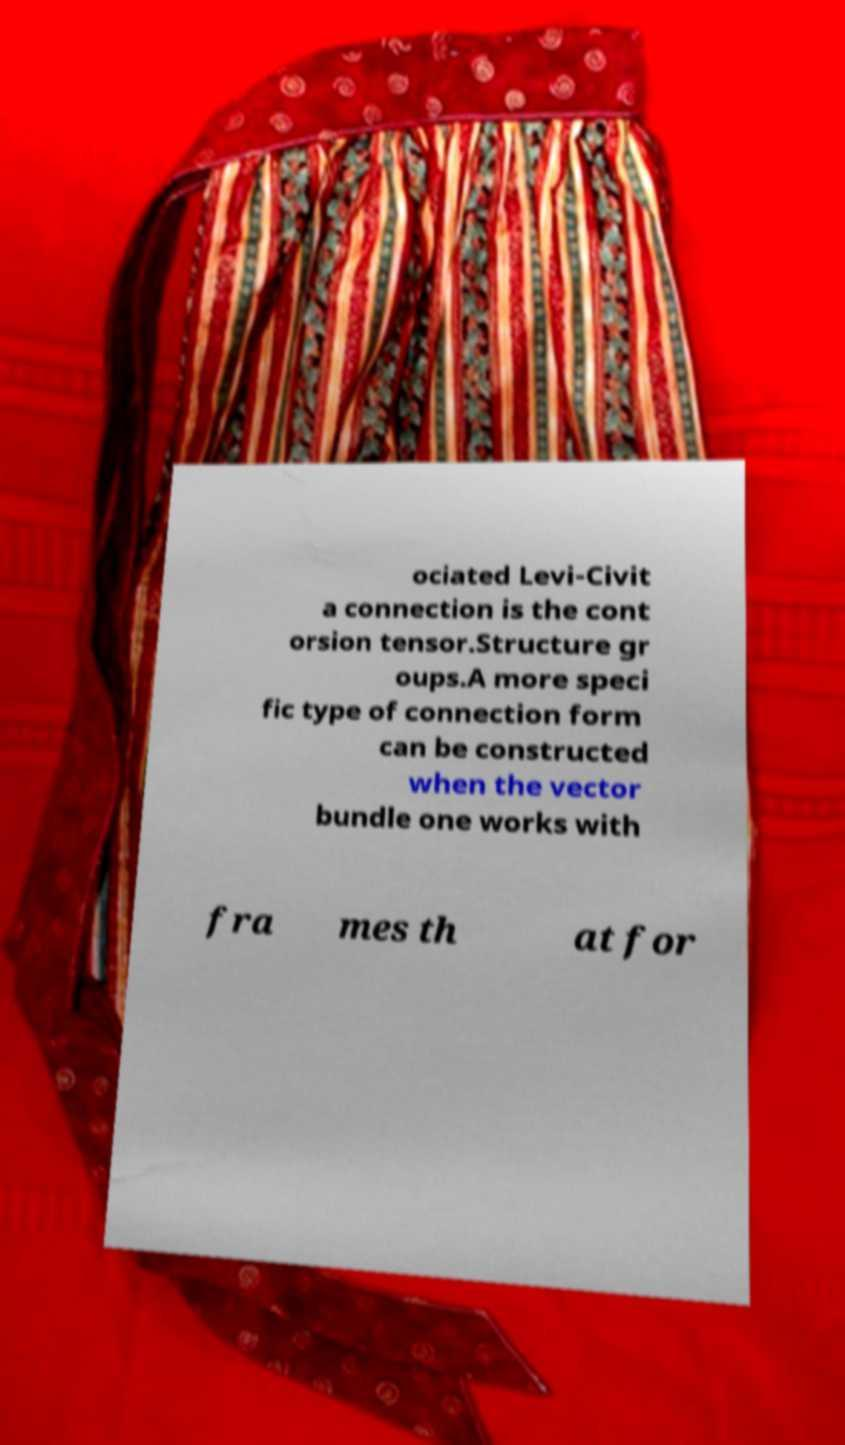Please read and relay the text visible in this image. What does it say? ociated Levi-Civit a connection is the cont orsion tensor.Structure gr oups.A more speci fic type of connection form can be constructed when the vector bundle one works with fra mes th at for 